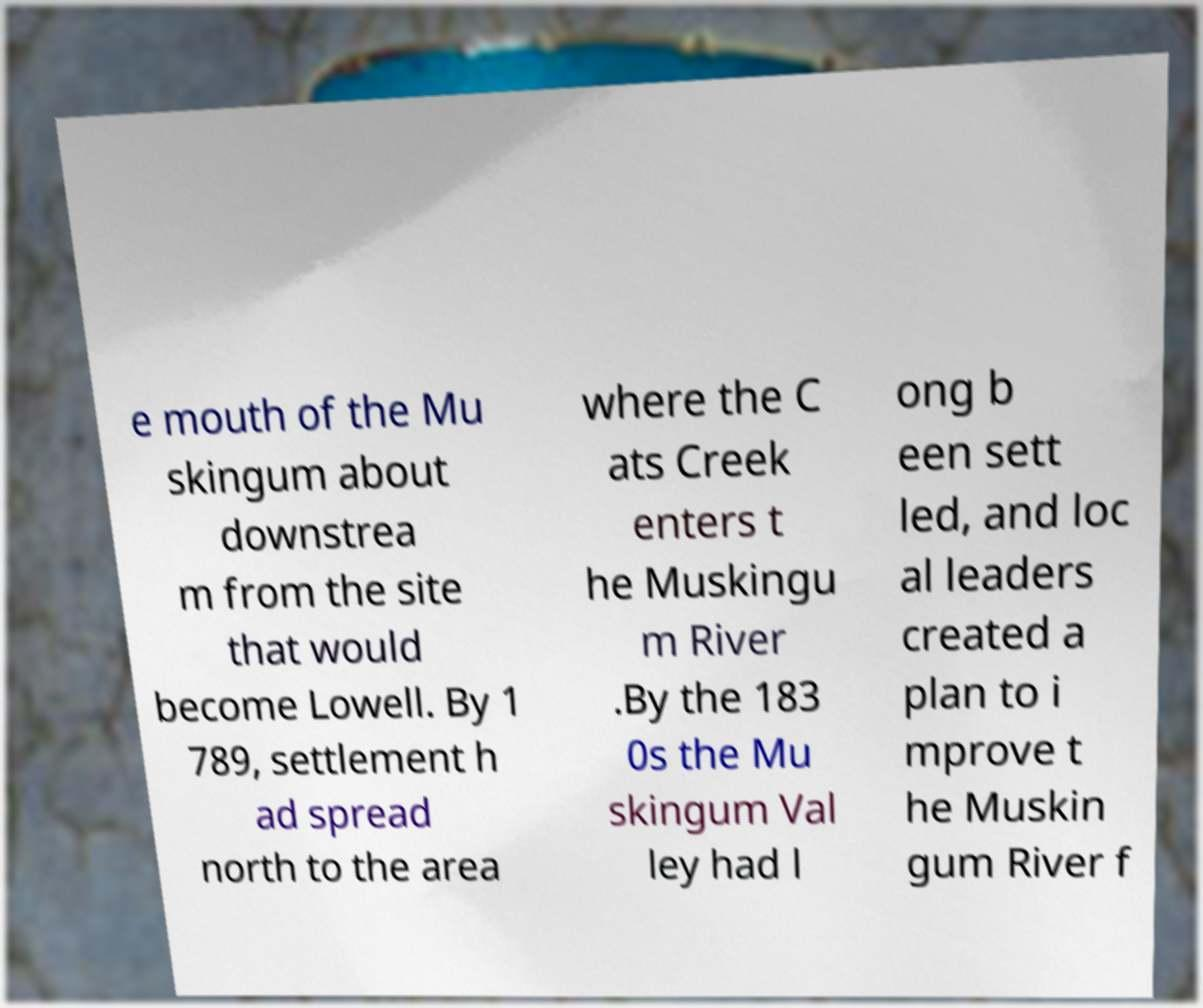Could you assist in decoding the text presented in this image and type it out clearly? e mouth of the Mu skingum about downstrea m from the site that would become Lowell. By 1 789, settlement h ad spread north to the area where the C ats Creek enters t he Muskingu m River .By the 183 0s the Mu skingum Val ley had l ong b een sett led, and loc al leaders created a plan to i mprove t he Muskin gum River f 